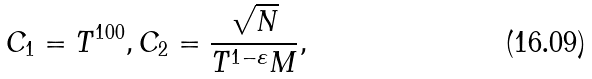<formula> <loc_0><loc_0><loc_500><loc_500>C _ { 1 } = T ^ { 1 0 0 } , C _ { 2 } = \frac { \sqrt { N } } { T ^ { 1 - \varepsilon } M } ,</formula> 